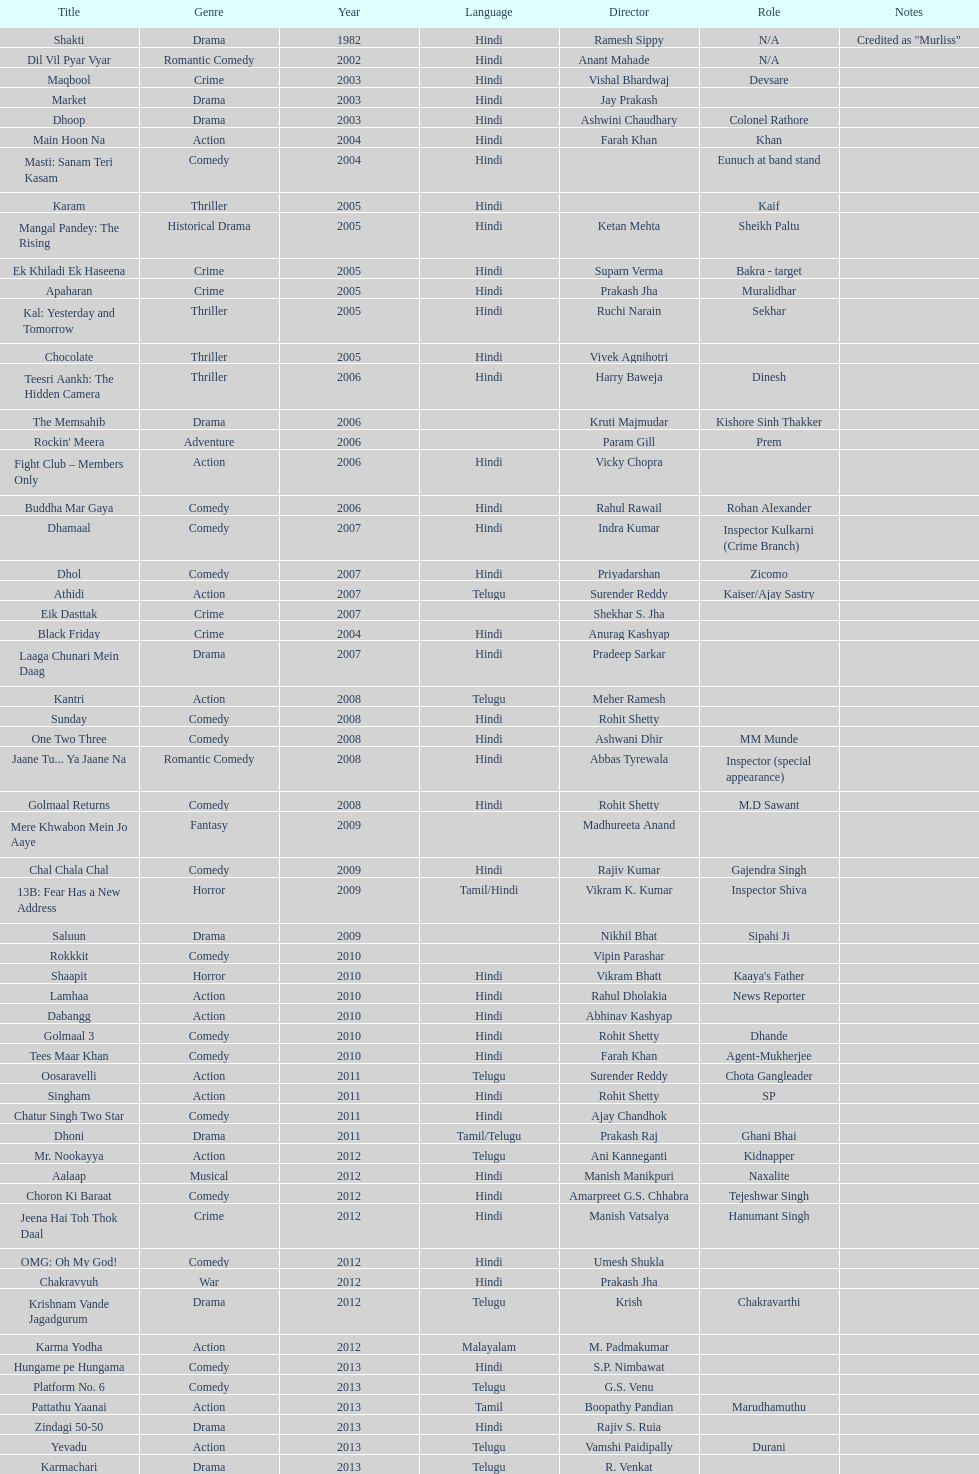Does maqbool have longer notes than shakti? No. 